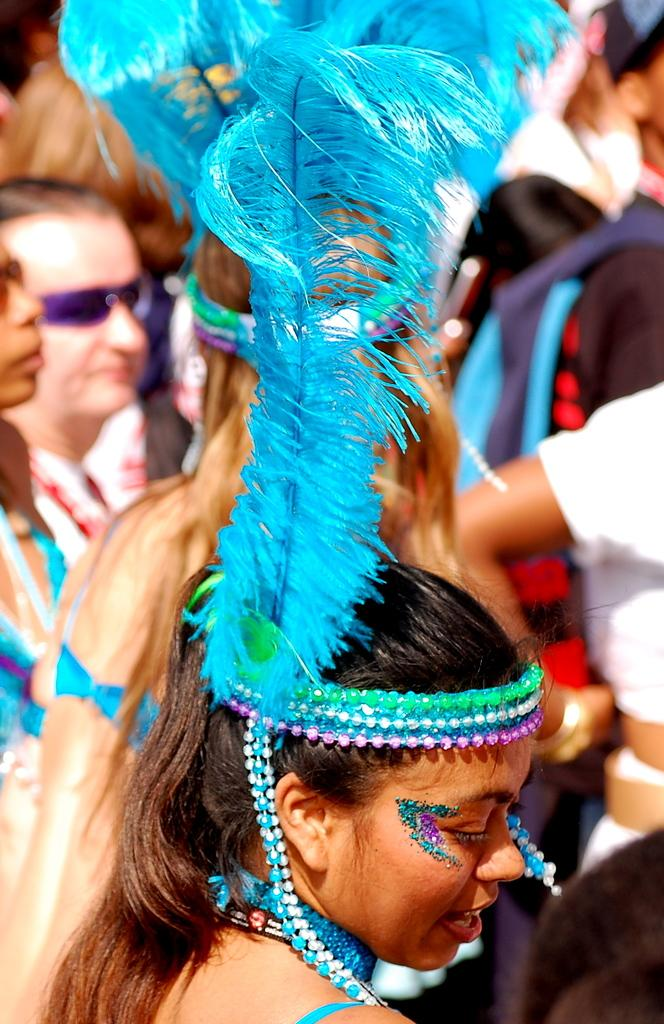How many people are in the image? There are many people in the image. Can you describe any specific clothing or accessories worn by someone in the image? Yes, a lady is wearing an object made of feathers. What type of border can be seen around the lady wearing the feather object in the image? There is no mention of a border around the lady in the image, so it cannot be determined from the provided facts. 